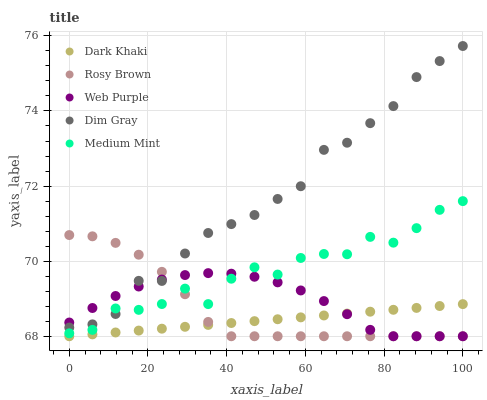Does Dark Khaki have the minimum area under the curve?
Answer yes or no. Yes. Does Dim Gray have the maximum area under the curve?
Answer yes or no. Yes. Does Medium Mint have the minimum area under the curve?
Answer yes or no. No. Does Medium Mint have the maximum area under the curve?
Answer yes or no. No. Is Dark Khaki the smoothest?
Answer yes or no. Yes. Is Medium Mint the roughest?
Answer yes or no. Yes. Is Web Purple the smoothest?
Answer yes or no. No. Is Web Purple the roughest?
Answer yes or no. No. Does Dark Khaki have the lowest value?
Answer yes or no. Yes. Does Medium Mint have the lowest value?
Answer yes or no. No. Does Dim Gray have the highest value?
Answer yes or no. Yes. Does Medium Mint have the highest value?
Answer yes or no. No. Is Dark Khaki less than Medium Mint?
Answer yes or no. Yes. Is Dim Gray greater than Dark Khaki?
Answer yes or no. Yes. Does Dark Khaki intersect Web Purple?
Answer yes or no. Yes. Is Dark Khaki less than Web Purple?
Answer yes or no. No. Is Dark Khaki greater than Web Purple?
Answer yes or no. No. Does Dark Khaki intersect Medium Mint?
Answer yes or no. No. 